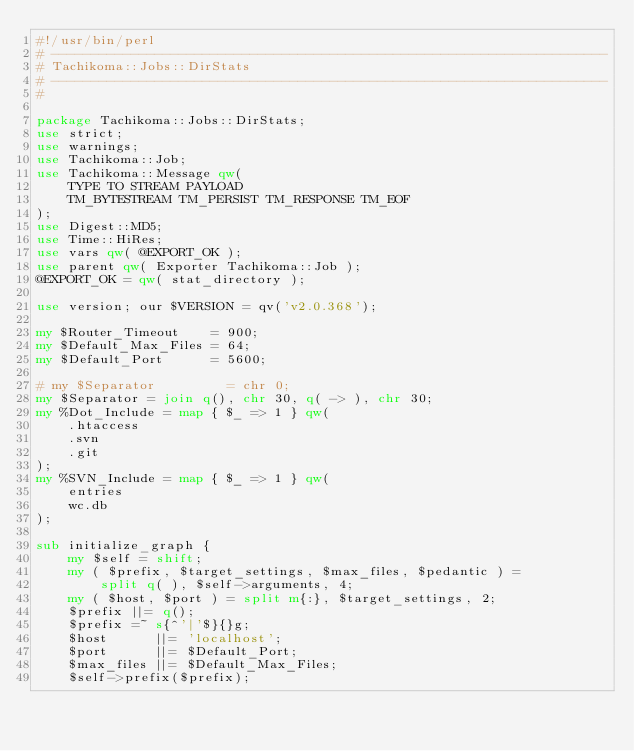Convert code to text. <code><loc_0><loc_0><loc_500><loc_500><_Perl_>#!/usr/bin/perl
# ----------------------------------------------------------------------
# Tachikoma::Jobs::DirStats
# ----------------------------------------------------------------------
#

package Tachikoma::Jobs::DirStats;
use strict;
use warnings;
use Tachikoma::Job;
use Tachikoma::Message qw(
    TYPE TO STREAM PAYLOAD
    TM_BYTESTREAM TM_PERSIST TM_RESPONSE TM_EOF
);
use Digest::MD5;
use Time::HiRes;
use vars qw( @EXPORT_OK );
use parent qw( Exporter Tachikoma::Job );
@EXPORT_OK = qw( stat_directory );

use version; our $VERSION = qv('v2.0.368');

my $Router_Timeout    = 900;
my $Default_Max_Files = 64;
my $Default_Port      = 5600;

# my $Separator         = chr 0;
my $Separator = join q(), chr 30, q( -> ), chr 30;
my %Dot_Include = map { $_ => 1 } qw(
    .htaccess
    .svn
    .git
);
my %SVN_Include = map { $_ => 1 } qw(
    entries
    wc.db
);

sub initialize_graph {
    my $self = shift;
    my ( $prefix, $target_settings, $max_files, $pedantic ) =
        split q( ), $self->arguments, 4;
    my ( $host, $port ) = split m{:}, $target_settings, 2;
    $prefix ||= q();
    $prefix =~ s{^'|'$}{}g;
    $host      ||= 'localhost';
    $port      ||= $Default_Port;
    $max_files ||= $Default_Max_Files;
    $self->prefix($prefix);</code> 